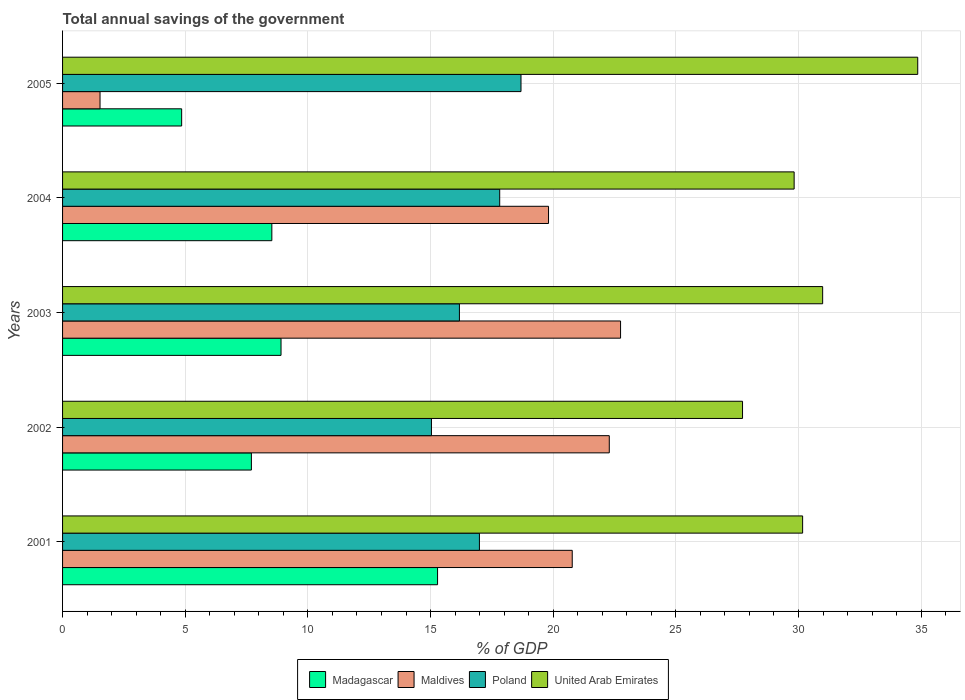How many different coloured bars are there?
Make the answer very short. 4. How many groups of bars are there?
Provide a short and direct response. 5. Are the number of bars on each tick of the Y-axis equal?
Provide a succinct answer. Yes. How many bars are there on the 5th tick from the bottom?
Your response must be concise. 4. What is the label of the 3rd group of bars from the top?
Your response must be concise. 2003. What is the total annual savings of the government in United Arab Emirates in 2004?
Offer a very short reply. 29.82. Across all years, what is the maximum total annual savings of the government in United Arab Emirates?
Your answer should be very brief. 34.86. Across all years, what is the minimum total annual savings of the government in United Arab Emirates?
Provide a succinct answer. 27.72. In which year was the total annual savings of the government in United Arab Emirates maximum?
Make the answer very short. 2005. What is the total total annual savings of the government in Poland in the graph?
Offer a very short reply. 84.71. What is the difference between the total annual savings of the government in Maldives in 2003 and that in 2004?
Make the answer very short. 2.94. What is the difference between the total annual savings of the government in Maldives in 2004 and the total annual savings of the government in Madagascar in 2002?
Provide a short and direct response. 12.11. What is the average total annual savings of the government in United Arab Emirates per year?
Your answer should be compact. 30.71. In the year 2004, what is the difference between the total annual savings of the government in Madagascar and total annual savings of the government in United Arab Emirates?
Make the answer very short. -21.29. What is the ratio of the total annual savings of the government in United Arab Emirates in 2003 to that in 2005?
Your response must be concise. 0.89. Is the total annual savings of the government in Madagascar in 2002 less than that in 2003?
Your response must be concise. Yes. What is the difference between the highest and the second highest total annual savings of the government in Maldives?
Provide a short and direct response. 0.46. What is the difference between the highest and the lowest total annual savings of the government in Madagascar?
Offer a very short reply. 10.43. In how many years, is the total annual savings of the government in Madagascar greater than the average total annual savings of the government in Madagascar taken over all years?
Offer a terse response. 1. Is it the case that in every year, the sum of the total annual savings of the government in United Arab Emirates and total annual savings of the government in Madagascar is greater than the sum of total annual savings of the government in Poland and total annual savings of the government in Maldives?
Provide a succinct answer. No. What does the 2nd bar from the top in 2005 represents?
Your answer should be compact. Poland. What does the 1st bar from the bottom in 2005 represents?
Give a very brief answer. Madagascar. Is it the case that in every year, the sum of the total annual savings of the government in Madagascar and total annual savings of the government in Poland is greater than the total annual savings of the government in United Arab Emirates?
Ensure brevity in your answer.  No. What is the difference between two consecutive major ticks on the X-axis?
Provide a short and direct response. 5. Are the values on the major ticks of X-axis written in scientific E-notation?
Keep it short and to the point. No. Where does the legend appear in the graph?
Your response must be concise. Bottom center. How many legend labels are there?
Keep it short and to the point. 4. How are the legend labels stacked?
Provide a succinct answer. Horizontal. What is the title of the graph?
Provide a short and direct response. Total annual savings of the government. What is the label or title of the X-axis?
Give a very brief answer. % of GDP. What is the label or title of the Y-axis?
Give a very brief answer. Years. What is the % of GDP of Madagascar in 2001?
Make the answer very short. 15.29. What is the % of GDP in Maldives in 2001?
Keep it short and to the point. 20.78. What is the % of GDP of Poland in 2001?
Offer a terse response. 16.99. What is the % of GDP of United Arab Emirates in 2001?
Make the answer very short. 30.17. What is the % of GDP in Madagascar in 2002?
Your answer should be very brief. 7.7. What is the % of GDP of Maldives in 2002?
Provide a short and direct response. 22.29. What is the % of GDP of Poland in 2002?
Ensure brevity in your answer.  15.04. What is the % of GDP of United Arab Emirates in 2002?
Your answer should be very brief. 27.72. What is the % of GDP in Madagascar in 2003?
Provide a succinct answer. 8.91. What is the % of GDP of Maldives in 2003?
Your answer should be compact. 22.75. What is the % of GDP of Poland in 2003?
Keep it short and to the point. 16.18. What is the % of GDP of United Arab Emirates in 2003?
Ensure brevity in your answer.  30.98. What is the % of GDP of Madagascar in 2004?
Your answer should be very brief. 8.53. What is the % of GDP in Maldives in 2004?
Make the answer very short. 19.81. What is the % of GDP of Poland in 2004?
Provide a succinct answer. 17.82. What is the % of GDP of United Arab Emirates in 2004?
Provide a short and direct response. 29.82. What is the % of GDP in Madagascar in 2005?
Offer a very short reply. 4.85. What is the % of GDP of Maldives in 2005?
Ensure brevity in your answer.  1.53. What is the % of GDP of Poland in 2005?
Ensure brevity in your answer.  18.69. What is the % of GDP in United Arab Emirates in 2005?
Provide a succinct answer. 34.86. Across all years, what is the maximum % of GDP of Madagascar?
Your response must be concise. 15.29. Across all years, what is the maximum % of GDP in Maldives?
Keep it short and to the point. 22.75. Across all years, what is the maximum % of GDP of Poland?
Keep it short and to the point. 18.69. Across all years, what is the maximum % of GDP in United Arab Emirates?
Your response must be concise. 34.86. Across all years, what is the minimum % of GDP of Madagascar?
Your answer should be compact. 4.85. Across all years, what is the minimum % of GDP in Maldives?
Offer a very short reply. 1.53. Across all years, what is the minimum % of GDP of Poland?
Keep it short and to the point. 15.04. Across all years, what is the minimum % of GDP of United Arab Emirates?
Offer a terse response. 27.72. What is the total % of GDP in Madagascar in the graph?
Offer a terse response. 45.27. What is the total % of GDP in Maldives in the graph?
Your answer should be very brief. 87.15. What is the total % of GDP of Poland in the graph?
Offer a very short reply. 84.71. What is the total % of GDP in United Arab Emirates in the graph?
Keep it short and to the point. 153.55. What is the difference between the % of GDP of Madagascar in 2001 and that in 2002?
Provide a succinct answer. 7.59. What is the difference between the % of GDP in Maldives in 2001 and that in 2002?
Keep it short and to the point. -1.51. What is the difference between the % of GDP in Poland in 2001 and that in 2002?
Ensure brevity in your answer.  1.95. What is the difference between the % of GDP in United Arab Emirates in 2001 and that in 2002?
Make the answer very short. 2.45. What is the difference between the % of GDP in Madagascar in 2001 and that in 2003?
Your answer should be very brief. 6.38. What is the difference between the % of GDP in Maldives in 2001 and that in 2003?
Your answer should be compact. -1.97. What is the difference between the % of GDP of Poland in 2001 and that in 2003?
Your answer should be compact. 0.82. What is the difference between the % of GDP in United Arab Emirates in 2001 and that in 2003?
Offer a very short reply. -0.82. What is the difference between the % of GDP of Madagascar in 2001 and that in 2004?
Give a very brief answer. 6.75. What is the difference between the % of GDP of Maldives in 2001 and that in 2004?
Keep it short and to the point. 0.97. What is the difference between the % of GDP in Poland in 2001 and that in 2004?
Your response must be concise. -0.83. What is the difference between the % of GDP of United Arab Emirates in 2001 and that in 2004?
Ensure brevity in your answer.  0.35. What is the difference between the % of GDP in Madagascar in 2001 and that in 2005?
Offer a terse response. 10.43. What is the difference between the % of GDP in Maldives in 2001 and that in 2005?
Your answer should be compact. 19.25. What is the difference between the % of GDP in Poland in 2001 and that in 2005?
Your answer should be very brief. -1.7. What is the difference between the % of GDP in United Arab Emirates in 2001 and that in 2005?
Provide a short and direct response. -4.69. What is the difference between the % of GDP of Madagascar in 2002 and that in 2003?
Provide a short and direct response. -1.21. What is the difference between the % of GDP of Maldives in 2002 and that in 2003?
Offer a terse response. -0.46. What is the difference between the % of GDP of Poland in 2002 and that in 2003?
Keep it short and to the point. -1.14. What is the difference between the % of GDP of United Arab Emirates in 2002 and that in 2003?
Your answer should be compact. -3.27. What is the difference between the % of GDP of Madagascar in 2002 and that in 2004?
Your response must be concise. -0.83. What is the difference between the % of GDP of Maldives in 2002 and that in 2004?
Ensure brevity in your answer.  2.48. What is the difference between the % of GDP of Poland in 2002 and that in 2004?
Provide a succinct answer. -2.78. What is the difference between the % of GDP of United Arab Emirates in 2002 and that in 2004?
Provide a succinct answer. -2.1. What is the difference between the % of GDP in Madagascar in 2002 and that in 2005?
Offer a terse response. 2.84. What is the difference between the % of GDP of Maldives in 2002 and that in 2005?
Give a very brief answer. 20.76. What is the difference between the % of GDP of Poland in 2002 and that in 2005?
Offer a terse response. -3.65. What is the difference between the % of GDP in United Arab Emirates in 2002 and that in 2005?
Offer a very short reply. -7.14. What is the difference between the % of GDP of Madagascar in 2003 and that in 2004?
Provide a succinct answer. 0.37. What is the difference between the % of GDP of Maldives in 2003 and that in 2004?
Your answer should be compact. 2.94. What is the difference between the % of GDP of Poland in 2003 and that in 2004?
Your response must be concise. -1.64. What is the difference between the % of GDP in United Arab Emirates in 2003 and that in 2004?
Your answer should be compact. 1.16. What is the difference between the % of GDP in Madagascar in 2003 and that in 2005?
Your answer should be very brief. 4.05. What is the difference between the % of GDP in Maldives in 2003 and that in 2005?
Provide a short and direct response. 21.22. What is the difference between the % of GDP in Poland in 2003 and that in 2005?
Give a very brief answer. -2.51. What is the difference between the % of GDP of United Arab Emirates in 2003 and that in 2005?
Your answer should be very brief. -3.88. What is the difference between the % of GDP of Madagascar in 2004 and that in 2005?
Your answer should be very brief. 3.68. What is the difference between the % of GDP of Maldives in 2004 and that in 2005?
Give a very brief answer. 18.28. What is the difference between the % of GDP of Poland in 2004 and that in 2005?
Provide a succinct answer. -0.87. What is the difference between the % of GDP in United Arab Emirates in 2004 and that in 2005?
Your response must be concise. -5.04. What is the difference between the % of GDP of Madagascar in 2001 and the % of GDP of Maldives in 2002?
Provide a succinct answer. -7. What is the difference between the % of GDP in Madagascar in 2001 and the % of GDP in Poland in 2002?
Your answer should be compact. 0.25. What is the difference between the % of GDP in Madagascar in 2001 and the % of GDP in United Arab Emirates in 2002?
Provide a succinct answer. -12.43. What is the difference between the % of GDP in Maldives in 2001 and the % of GDP in Poland in 2002?
Offer a terse response. 5.74. What is the difference between the % of GDP in Maldives in 2001 and the % of GDP in United Arab Emirates in 2002?
Keep it short and to the point. -6.94. What is the difference between the % of GDP in Poland in 2001 and the % of GDP in United Arab Emirates in 2002?
Your response must be concise. -10.73. What is the difference between the % of GDP in Madagascar in 2001 and the % of GDP in Maldives in 2003?
Offer a very short reply. -7.46. What is the difference between the % of GDP of Madagascar in 2001 and the % of GDP of Poland in 2003?
Ensure brevity in your answer.  -0.89. What is the difference between the % of GDP in Madagascar in 2001 and the % of GDP in United Arab Emirates in 2003?
Give a very brief answer. -15.7. What is the difference between the % of GDP of Maldives in 2001 and the % of GDP of Poland in 2003?
Your answer should be very brief. 4.6. What is the difference between the % of GDP in Maldives in 2001 and the % of GDP in United Arab Emirates in 2003?
Provide a short and direct response. -10.21. What is the difference between the % of GDP in Poland in 2001 and the % of GDP in United Arab Emirates in 2003?
Your answer should be compact. -13.99. What is the difference between the % of GDP of Madagascar in 2001 and the % of GDP of Maldives in 2004?
Ensure brevity in your answer.  -4.52. What is the difference between the % of GDP of Madagascar in 2001 and the % of GDP of Poland in 2004?
Offer a terse response. -2.53. What is the difference between the % of GDP of Madagascar in 2001 and the % of GDP of United Arab Emirates in 2004?
Provide a short and direct response. -14.54. What is the difference between the % of GDP in Maldives in 2001 and the % of GDP in Poland in 2004?
Offer a very short reply. 2.96. What is the difference between the % of GDP in Maldives in 2001 and the % of GDP in United Arab Emirates in 2004?
Ensure brevity in your answer.  -9.05. What is the difference between the % of GDP of Poland in 2001 and the % of GDP of United Arab Emirates in 2004?
Your response must be concise. -12.83. What is the difference between the % of GDP of Madagascar in 2001 and the % of GDP of Maldives in 2005?
Your response must be concise. 13.76. What is the difference between the % of GDP in Madagascar in 2001 and the % of GDP in Poland in 2005?
Give a very brief answer. -3.4. What is the difference between the % of GDP in Madagascar in 2001 and the % of GDP in United Arab Emirates in 2005?
Provide a succinct answer. -19.57. What is the difference between the % of GDP in Maldives in 2001 and the % of GDP in Poland in 2005?
Offer a terse response. 2.09. What is the difference between the % of GDP in Maldives in 2001 and the % of GDP in United Arab Emirates in 2005?
Make the answer very short. -14.08. What is the difference between the % of GDP in Poland in 2001 and the % of GDP in United Arab Emirates in 2005?
Your answer should be very brief. -17.87. What is the difference between the % of GDP of Madagascar in 2002 and the % of GDP of Maldives in 2003?
Offer a very short reply. -15.05. What is the difference between the % of GDP of Madagascar in 2002 and the % of GDP of Poland in 2003?
Provide a succinct answer. -8.48. What is the difference between the % of GDP of Madagascar in 2002 and the % of GDP of United Arab Emirates in 2003?
Make the answer very short. -23.29. What is the difference between the % of GDP of Maldives in 2002 and the % of GDP of Poland in 2003?
Your answer should be very brief. 6.11. What is the difference between the % of GDP in Maldives in 2002 and the % of GDP in United Arab Emirates in 2003?
Your answer should be compact. -8.7. What is the difference between the % of GDP in Poland in 2002 and the % of GDP in United Arab Emirates in 2003?
Make the answer very short. -15.95. What is the difference between the % of GDP in Madagascar in 2002 and the % of GDP in Maldives in 2004?
Provide a short and direct response. -12.11. What is the difference between the % of GDP in Madagascar in 2002 and the % of GDP in Poland in 2004?
Make the answer very short. -10.12. What is the difference between the % of GDP in Madagascar in 2002 and the % of GDP in United Arab Emirates in 2004?
Provide a short and direct response. -22.12. What is the difference between the % of GDP in Maldives in 2002 and the % of GDP in Poland in 2004?
Your response must be concise. 4.47. What is the difference between the % of GDP of Maldives in 2002 and the % of GDP of United Arab Emirates in 2004?
Keep it short and to the point. -7.54. What is the difference between the % of GDP of Poland in 2002 and the % of GDP of United Arab Emirates in 2004?
Ensure brevity in your answer.  -14.78. What is the difference between the % of GDP in Madagascar in 2002 and the % of GDP in Maldives in 2005?
Your response must be concise. 6.17. What is the difference between the % of GDP in Madagascar in 2002 and the % of GDP in Poland in 2005?
Keep it short and to the point. -10.99. What is the difference between the % of GDP in Madagascar in 2002 and the % of GDP in United Arab Emirates in 2005?
Offer a terse response. -27.16. What is the difference between the % of GDP of Maldives in 2002 and the % of GDP of Poland in 2005?
Keep it short and to the point. 3.6. What is the difference between the % of GDP in Maldives in 2002 and the % of GDP in United Arab Emirates in 2005?
Your answer should be compact. -12.57. What is the difference between the % of GDP in Poland in 2002 and the % of GDP in United Arab Emirates in 2005?
Offer a terse response. -19.82. What is the difference between the % of GDP of Madagascar in 2003 and the % of GDP of Maldives in 2004?
Offer a very short reply. -10.9. What is the difference between the % of GDP in Madagascar in 2003 and the % of GDP in Poland in 2004?
Give a very brief answer. -8.91. What is the difference between the % of GDP of Madagascar in 2003 and the % of GDP of United Arab Emirates in 2004?
Ensure brevity in your answer.  -20.92. What is the difference between the % of GDP in Maldives in 2003 and the % of GDP in Poland in 2004?
Your response must be concise. 4.93. What is the difference between the % of GDP of Maldives in 2003 and the % of GDP of United Arab Emirates in 2004?
Your response must be concise. -7.08. What is the difference between the % of GDP in Poland in 2003 and the % of GDP in United Arab Emirates in 2004?
Your answer should be compact. -13.64. What is the difference between the % of GDP of Madagascar in 2003 and the % of GDP of Maldives in 2005?
Your answer should be compact. 7.38. What is the difference between the % of GDP in Madagascar in 2003 and the % of GDP in Poland in 2005?
Your answer should be very brief. -9.78. What is the difference between the % of GDP in Madagascar in 2003 and the % of GDP in United Arab Emirates in 2005?
Your answer should be compact. -25.95. What is the difference between the % of GDP of Maldives in 2003 and the % of GDP of Poland in 2005?
Your answer should be compact. 4.06. What is the difference between the % of GDP of Maldives in 2003 and the % of GDP of United Arab Emirates in 2005?
Your answer should be very brief. -12.11. What is the difference between the % of GDP in Poland in 2003 and the % of GDP in United Arab Emirates in 2005?
Your answer should be compact. -18.68. What is the difference between the % of GDP in Madagascar in 2004 and the % of GDP in Maldives in 2005?
Provide a short and direct response. 7. What is the difference between the % of GDP in Madagascar in 2004 and the % of GDP in Poland in 2005?
Provide a succinct answer. -10.16. What is the difference between the % of GDP of Madagascar in 2004 and the % of GDP of United Arab Emirates in 2005?
Provide a short and direct response. -26.33. What is the difference between the % of GDP in Maldives in 2004 and the % of GDP in Poland in 2005?
Make the answer very short. 1.12. What is the difference between the % of GDP in Maldives in 2004 and the % of GDP in United Arab Emirates in 2005?
Make the answer very short. -15.05. What is the difference between the % of GDP in Poland in 2004 and the % of GDP in United Arab Emirates in 2005?
Keep it short and to the point. -17.04. What is the average % of GDP of Madagascar per year?
Give a very brief answer. 9.05. What is the average % of GDP of Maldives per year?
Make the answer very short. 17.43. What is the average % of GDP of Poland per year?
Give a very brief answer. 16.94. What is the average % of GDP in United Arab Emirates per year?
Provide a short and direct response. 30.71. In the year 2001, what is the difference between the % of GDP of Madagascar and % of GDP of Maldives?
Your answer should be very brief. -5.49. In the year 2001, what is the difference between the % of GDP in Madagascar and % of GDP in Poland?
Provide a short and direct response. -1.71. In the year 2001, what is the difference between the % of GDP of Madagascar and % of GDP of United Arab Emirates?
Provide a succinct answer. -14.88. In the year 2001, what is the difference between the % of GDP of Maldives and % of GDP of Poland?
Provide a short and direct response. 3.78. In the year 2001, what is the difference between the % of GDP of Maldives and % of GDP of United Arab Emirates?
Offer a terse response. -9.39. In the year 2001, what is the difference between the % of GDP in Poland and % of GDP in United Arab Emirates?
Your answer should be compact. -13.18. In the year 2002, what is the difference between the % of GDP in Madagascar and % of GDP in Maldives?
Make the answer very short. -14.59. In the year 2002, what is the difference between the % of GDP of Madagascar and % of GDP of Poland?
Offer a very short reply. -7.34. In the year 2002, what is the difference between the % of GDP in Madagascar and % of GDP in United Arab Emirates?
Your answer should be compact. -20.02. In the year 2002, what is the difference between the % of GDP in Maldives and % of GDP in Poland?
Your response must be concise. 7.25. In the year 2002, what is the difference between the % of GDP of Maldives and % of GDP of United Arab Emirates?
Keep it short and to the point. -5.43. In the year 2002, what is the difference between the % of GDP of Poland and % of GDP of United Arab Emirates?
Your answer should be compact. -12.68. In the year 2003, what is the difference between the % of GDP in Madagascar and % of GDP in Maldives?
Your answer should be very brief. -13.84. In the year 2003, what is the difference between the % of GDP in Madagascar and % of GDP in Poland?
Offer a terse response. -7.27. In the year 2003, what is the difference between the % of GDP in Madagascar and % of GDP in United Arab Emirates?
Your answer should be compact. -22.08. In the year 2003, what is the difference between the % of GDP of Maldives and % of GDP of Poland?
Your answer should be compact. 6.57. In the year 2003, what is the difference between the % of GDP in Maldives and % of GDP in United Arab Emirates?
Your answer should be compact. -8.24. In the year 2003, what is the difference between the % of GDP of Poland and % of GDP of United Arab Emirates?
Give a very brief answer. -14.81. In the year 2004, what is the difference between the % of GDP in Madagascar and % of GDP in Maldives?
Your answer should be very brief. -11.28. In the year 2004, what is the difference between the % of GDP of Madagascar and % of GDP of Poland?
Your answer should be very brief. -9.29. In the year 2004, what is the difference between the % of GDP in Madagascar and % of GDP in United Arab Emirates?
Keep it short and to the point. -21.29. In the year 2004, what is the difference between the % of GDP of Maldives and % of GDP of Poland?
Your answer should be very brief. 1.99. In the year 2004, what is the difference between the % of GDP in Maldives and % of GDP in United Arab Emirates?
Your answer should be very brief. -10.01. In the year 2004, what is the difference between the % of GDP of Poland and % of GDP of United Arab Emirates?
Your answer should be compact. -12. In the year 2005, what is the difference between the % of GDP in Madagascar and % of GDP in Maldives?
Offer a terse response. 3.33. In the year 2005, what is the difference between the % of GDP in Madagascar and % of GDP in Poland?
Your response must be concise. -13.83. In the year 2005, what is the difference between the % of GDP of Madagascar and % of GDP of United Arab Emirates?
Ensure brevity in your answer.  -30.01. In the year 2005, what is the difference between the % of GDP in Maldives and % of GDP in Poland?
Provide a succinct answer. -17.16. In the year 2005, what is the difference between the % of GDP in Maldives and % of GDP in United Arab Emirates?
Provide a succinct answer. -33.33. In the year 2005, what is the difference between the % of GDP of Poland and % of GDP of United Arab Emirates?
Your answer should be compact. -16.17. What is the ratio of the % of GDP in Madagascar in 2001 to that in 2002?
Give a very brief answer. 1.99. What is the ratio of the % of GDP of Maldives in 2001 to that in 2002?
Provide a short and direct response. 0.93. What is the ratio of the % of GDP in Poland in 2001 to that in 2002?
Make the answer very short. 1.13. What is the ratio of the % of GDP in United Arab Emirates in 2001 to that in 2002?
Offer a terse response. 1.09. What is the ratio of the % of GDP of Madagascar in 2001 to that in 2003?
Provide a succinct answer. 1.72. What is the ratio of the % of GDP of Maldives in 2001 to that in 2003?
Your answer should be compact. 0.91. What is the ratio of the % of GDP in Poland in 2001 to that in 2003?
Your response must be concise. 1.05. What is the ratio of the % of GDP of United Arab Emirates in 2001 to that in 2003?
Your response must be concise. 0.97. What is the ratio of the % of GDP of Madagascar in 2001 to that in 2004?
Provide a succinct answer. 1.79. What is the ratio of the % of GDP of Maldives in 2001 to that in 2004?
Make the answer very short. 1.05. What is the ratio of the % of GDP of Poland in 2001 to that in 2004?
Make the answer very short. 0.95. What is the ratio of the % of GDP of United Arab Emirates in 2001 to that in 2004?
Provide a succinct answer. 1.01. What is the ratio of the % of GDP of Madagascar in 2001 to that in 2005?
Offer a very short reply. 3.15. What is the ratio of the % of GDP in Maldives in 2001 to that in 2005?
Your answer should be very brief. 13.6. What is the ratio of the % of GDP of Poland in 2001 to that in 2005?
Make the answer very short. 0.91. What is the ratio of the % of GDP of United Arab Emirates in 2001 to that in 2005?
Your answer should be very brief. 0.87. What is the ratio of the % of GDP in Madagascar in 2002 to that in 2003?
Your answer should be very brief. 0.86. What is the ratio of the % of GDP in Maldives in 2002 to that in 2003?
Make the answer very short. 0.98. What is the ratio of the % of GDP of Poland in 2002 to that in 2003?
Provide a succinct answer. 0.93. What is the ratio of the % of GDP in United Arab Emirates in 2002 to that in 2003?
Make the answer very short. 0.89. What is the ratio of the % of GDP of Madagascar in 2002 to that in 2004?
Your response must be concise. 0.9. What is the ratio of the % of GDP in Maldives in 2002 to that in 2004?
Provide a short and direct response. 1.12. What is the ratio of the % of GDP of Poland in 2002 to that in 2004?
Your answer should be compact. 0.84. What is the ratio of the % of GDP of United Arab Emirates in 2002 to that in 2004?
Give a very brief answer. 0.93. What is the ratio of the % of GDP of Madagascar in 2002 to that in 2005?
Provide a succinct answer. 1.59. What is the ratio of the % of GDP in Maldives in 2002 to that in 2005?
Provide a short and direct response. 14.59. What is the ratio of the % of GDP in Poland in 2002 to that in 2005?
Your answer should be very brief. 0.8. What is the ratio of the % of GDP in United Arab Emirates in 2002 to that in 2005?
Give a very brief answer. 0.8. What is the ratio of the % of GDP of Madagascar in 2003 to that in 2004?
Provide a succinct answer. 1.04. What is the ratio of the % of GDP of Maldives in 2003 to that in 2004?
Your answer should be compact. 1.15. What is the ratio of the % of GDP of Poland in 2003 to that in 2004?
Your answer should be very brief. 0.91. What is the ratio of the % of GDP in United Arab Emirates in 2003 to that in 2004?
Make the answer very short. 1.04. What is the ratio of the % of GDP of Madagascar in 2003 to that in 2005?
Your answer should be compact. 1.83. What is the ratio of the % of GDP in Maldives in 2003 to that in 2005?
Your response must be concise. 14.89. What is the ratio of the % of GDP in Poland in 2003 to that in 2005?
Provide a short and direct response. 0.87. What is the ratio of the % of GDP of United Arab Emirates in 2003 to that in 2005?
Provide a short and direct response. 0.89. What is the ratio of the % of GDP of Madagascar in 2004 to that in 2005?
Ensure brevity in your answer.  1.76. What is the ratio of the % of GDP of Maldives in 2004 to that in 2005?
Keep it short and to the point. 12.97. What is the ratio of the % of GDP of Poland in 2004 to that in 2005?
Your response must be concise. 0.95. What is the ratio of the % of GDP of United Arab Emirates in 2004 to that in 2005?
Your response must be concise. 0.86. What is the difference between the highest and the second highest % of GDP of Madagascar?
Provide a succinct answer. 6.38. What is the difference between the highest and the second highest % of GDP in Maldives?
Offer a terse response. 0.46. What is the difference between the highest and the second highest % of GDP of Poland?
Offer a terse response. 0.87. What is the difference between the highest and the second highest % of GDP in United Arab Emirates?
Provide a succinct answer. 3.88. What is the difference between the highest and the lowest % of GDP in Madagascar?
Ensure brevity in your answer.  10.43. What is the difference between the highest and the lowest % of GDP in Maldives?
Your answer should be compact. 21.22. What is the difference between the highest and the lowest % of GDP in Poland?
Make the answer very short. 3.65. What is the difference between the highest and the lowest % of GDP of United Arab Emirates?
Provide a short and direct response. 7.14. 